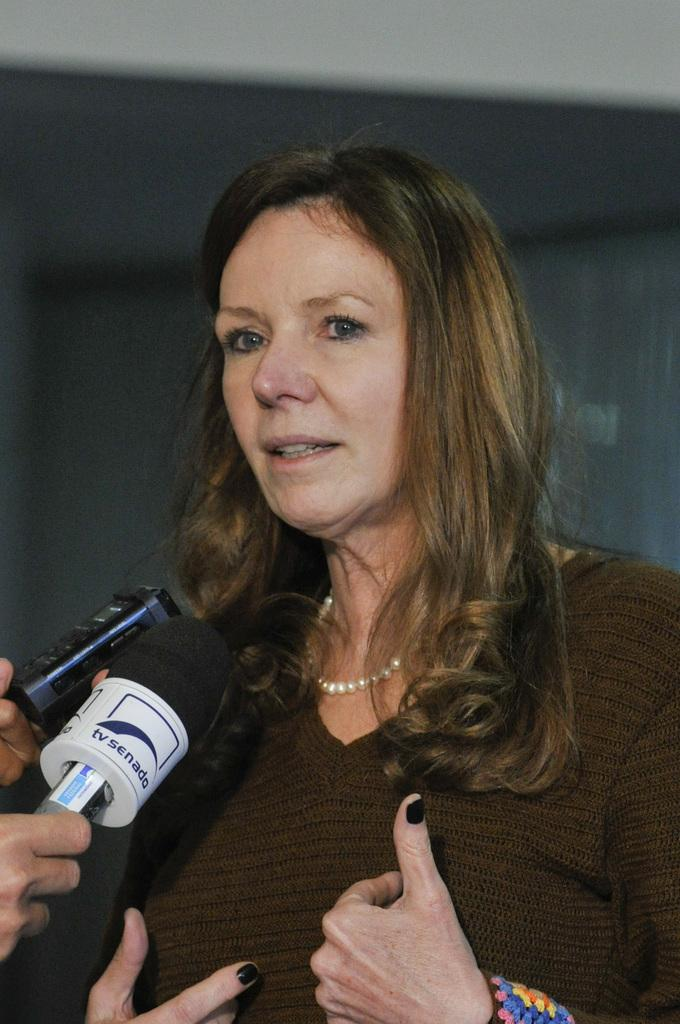Who is the main subject in the foreground of the image? There is a woman in the foreground of the image. What object is also present in the foreground with the woman? There is a microphone (mike) in the foreground of the image. What can be seen in the background of the image? There is a wall in the background of the image. Can you describe the possible setting of the image? The image may have been taken in a hall. How many friends are on the boat in the image? There is no boat or friends present in the image. 